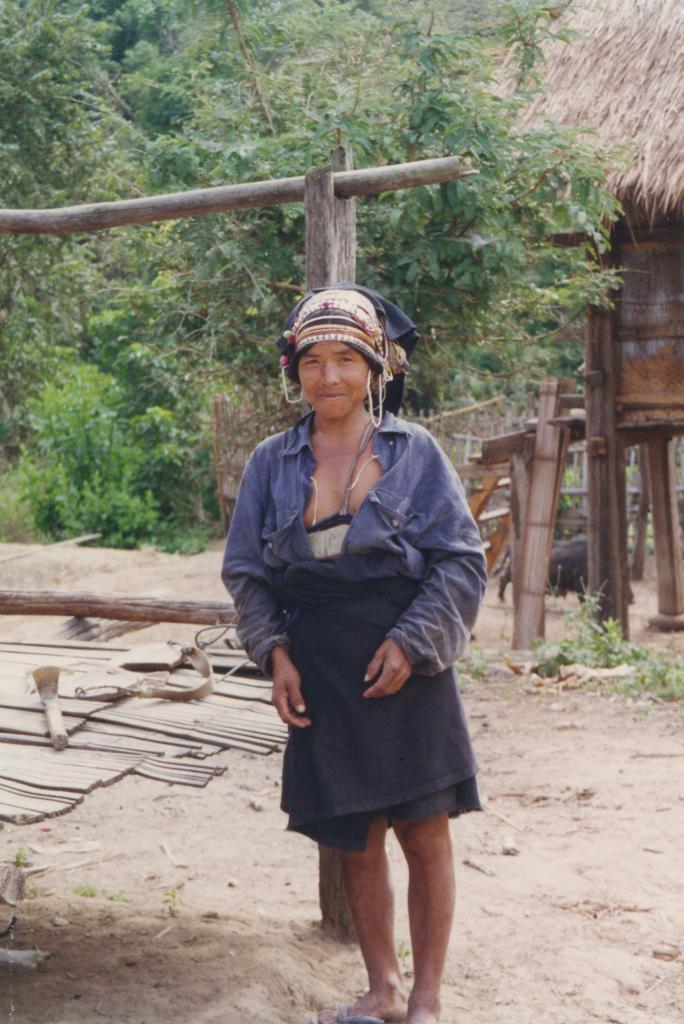In one or two sentences, can you explain what this image depicts? In the foreground of the image we can see a woman wearing dress and cap is standing on the ground. In the background, we can see wooden poles, a hut, staircase, a group of trees and a fence. 